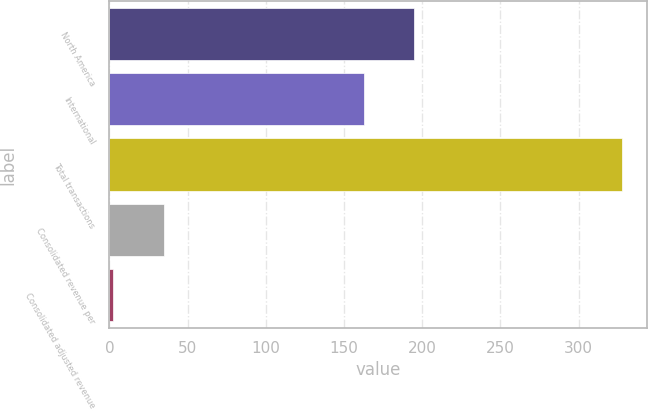Convert chart. <chart><loc_0><loc_0><loc_500><loc_500><bar_chart><fcel>North America<fcel>International<fcel>Total transactions<fcel>Consolidated revenue per<fcel>Consolidated adjusted revenue<nl><fcel>195<fcel>162.5<fcel>327.5<fcel>35.03<fcel>2.53<nl></chart> 